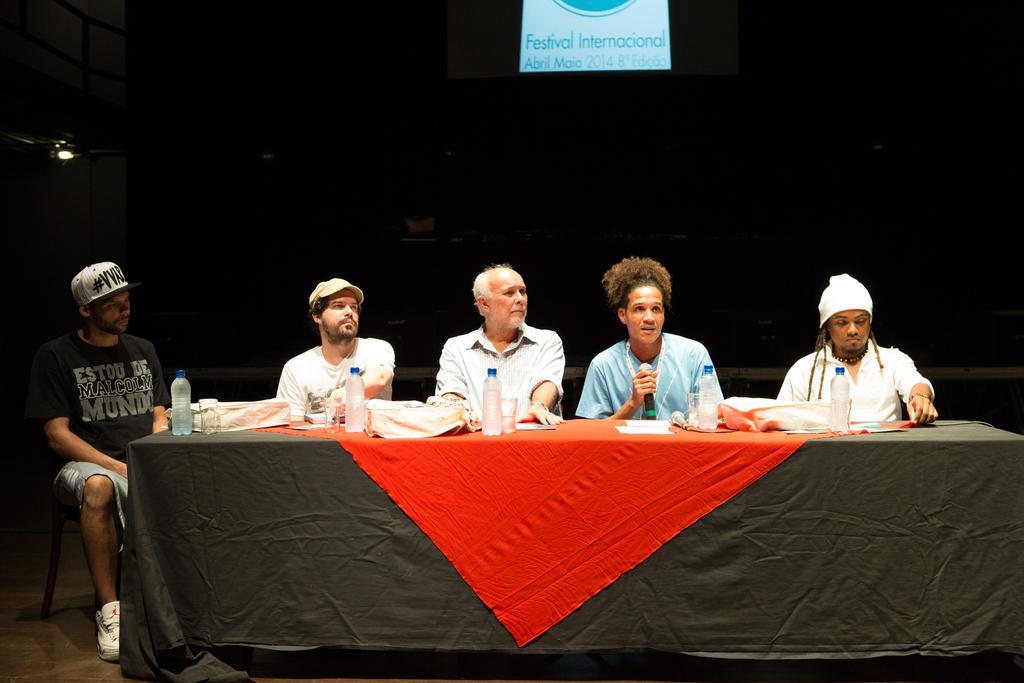Please provide a concise description of this image. In this image, we can see persons in front of the table. This table contains bottles, bags and glasses. There is a person in the middle of the image holding a mic with his hand. There is a screen at the top of the image. 